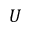Convert formula to latex. <formula><loc_0><loc_0><loc_500><loc_500>U</formula> 